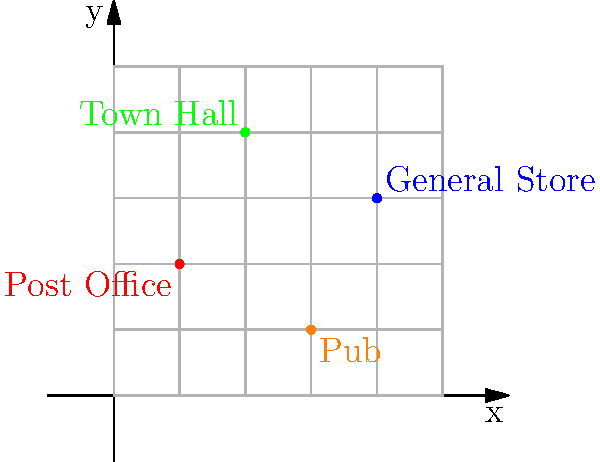In the map of Wattle Creek town center, what are the coordinates of the General Store? To find the coordinates of the General Store, let's follow these steps:

1. Identify the General Store on the map. It's labeled in blue.

2. Look at the x-axis (horizontal) to determine the x-coordinate:
   - The General Store is located 4 units to the right of the origin.
   - Therefore, the x-coordinate is 4.

3. Look at the y-axis (vertical) to determine the y-coordinate:
   - The General Store is located 3 units up from the origin.
   - Therefore, the y-coordinate is 3.

4. Combine the x and y coordinates in the format $(x, y)$.

Thus, the coordinates of the General Store are $(4, 3)$.
Answer: $(4, 3)$ 